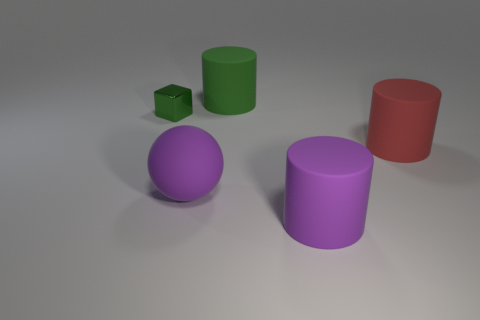Is the number of matte objects left of the small metal block greater than the number of purple matte cylinders to the right of the large red matte object?
Make the answer very short. No. What shape is the big matte object that is on the right side of the purple thing that is on the right side of the large thing that is behind the large red rubber object?
Keep it short and to the point. Cylinder. What is the shape of the rubber thing that is to the right of the cylinder in front of the rubber ball?
Provide a short and direct response. Cylinder. Is there a tiny thing made of the same material as the purple cylinder?
Provide a short and direct response. No. There is a thing that is the same color as the sphere; what size is it?
Your answer should be very brief. Large. How many red things are either rubber things or tiny metal cylinders?
Make the answer very short. 1. Are there any large cylinders of the same color as the tiny metal object?
Offer a very short reply. Yes. What size is the green cylinder that is the same material as the red cylinder?
Make the answer very short. Large. How many blocks are either gray objects or purple rubber objects?
Offer a very short reply. 0. Is the number of big purple cylinders greater than the number of rubber things?
Keep it short and to the point. No. 